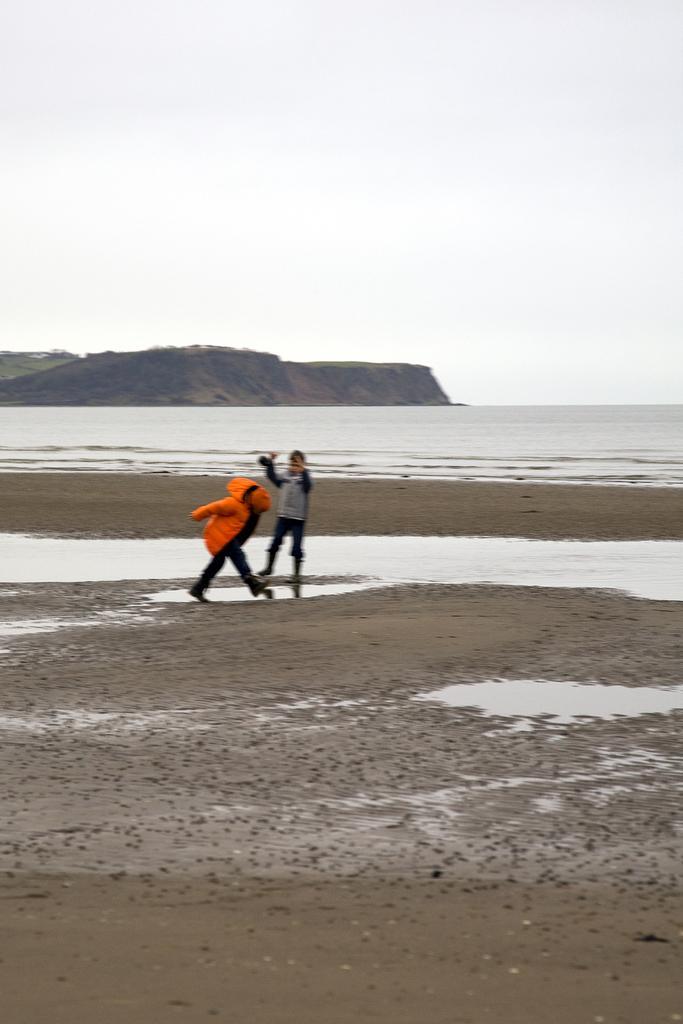In one or two sentences, can you explain what this image depicts? In this image I can see in the middle there are two persons, at the back side there is water. On the left side there is a hill, at the top it is the sky. 